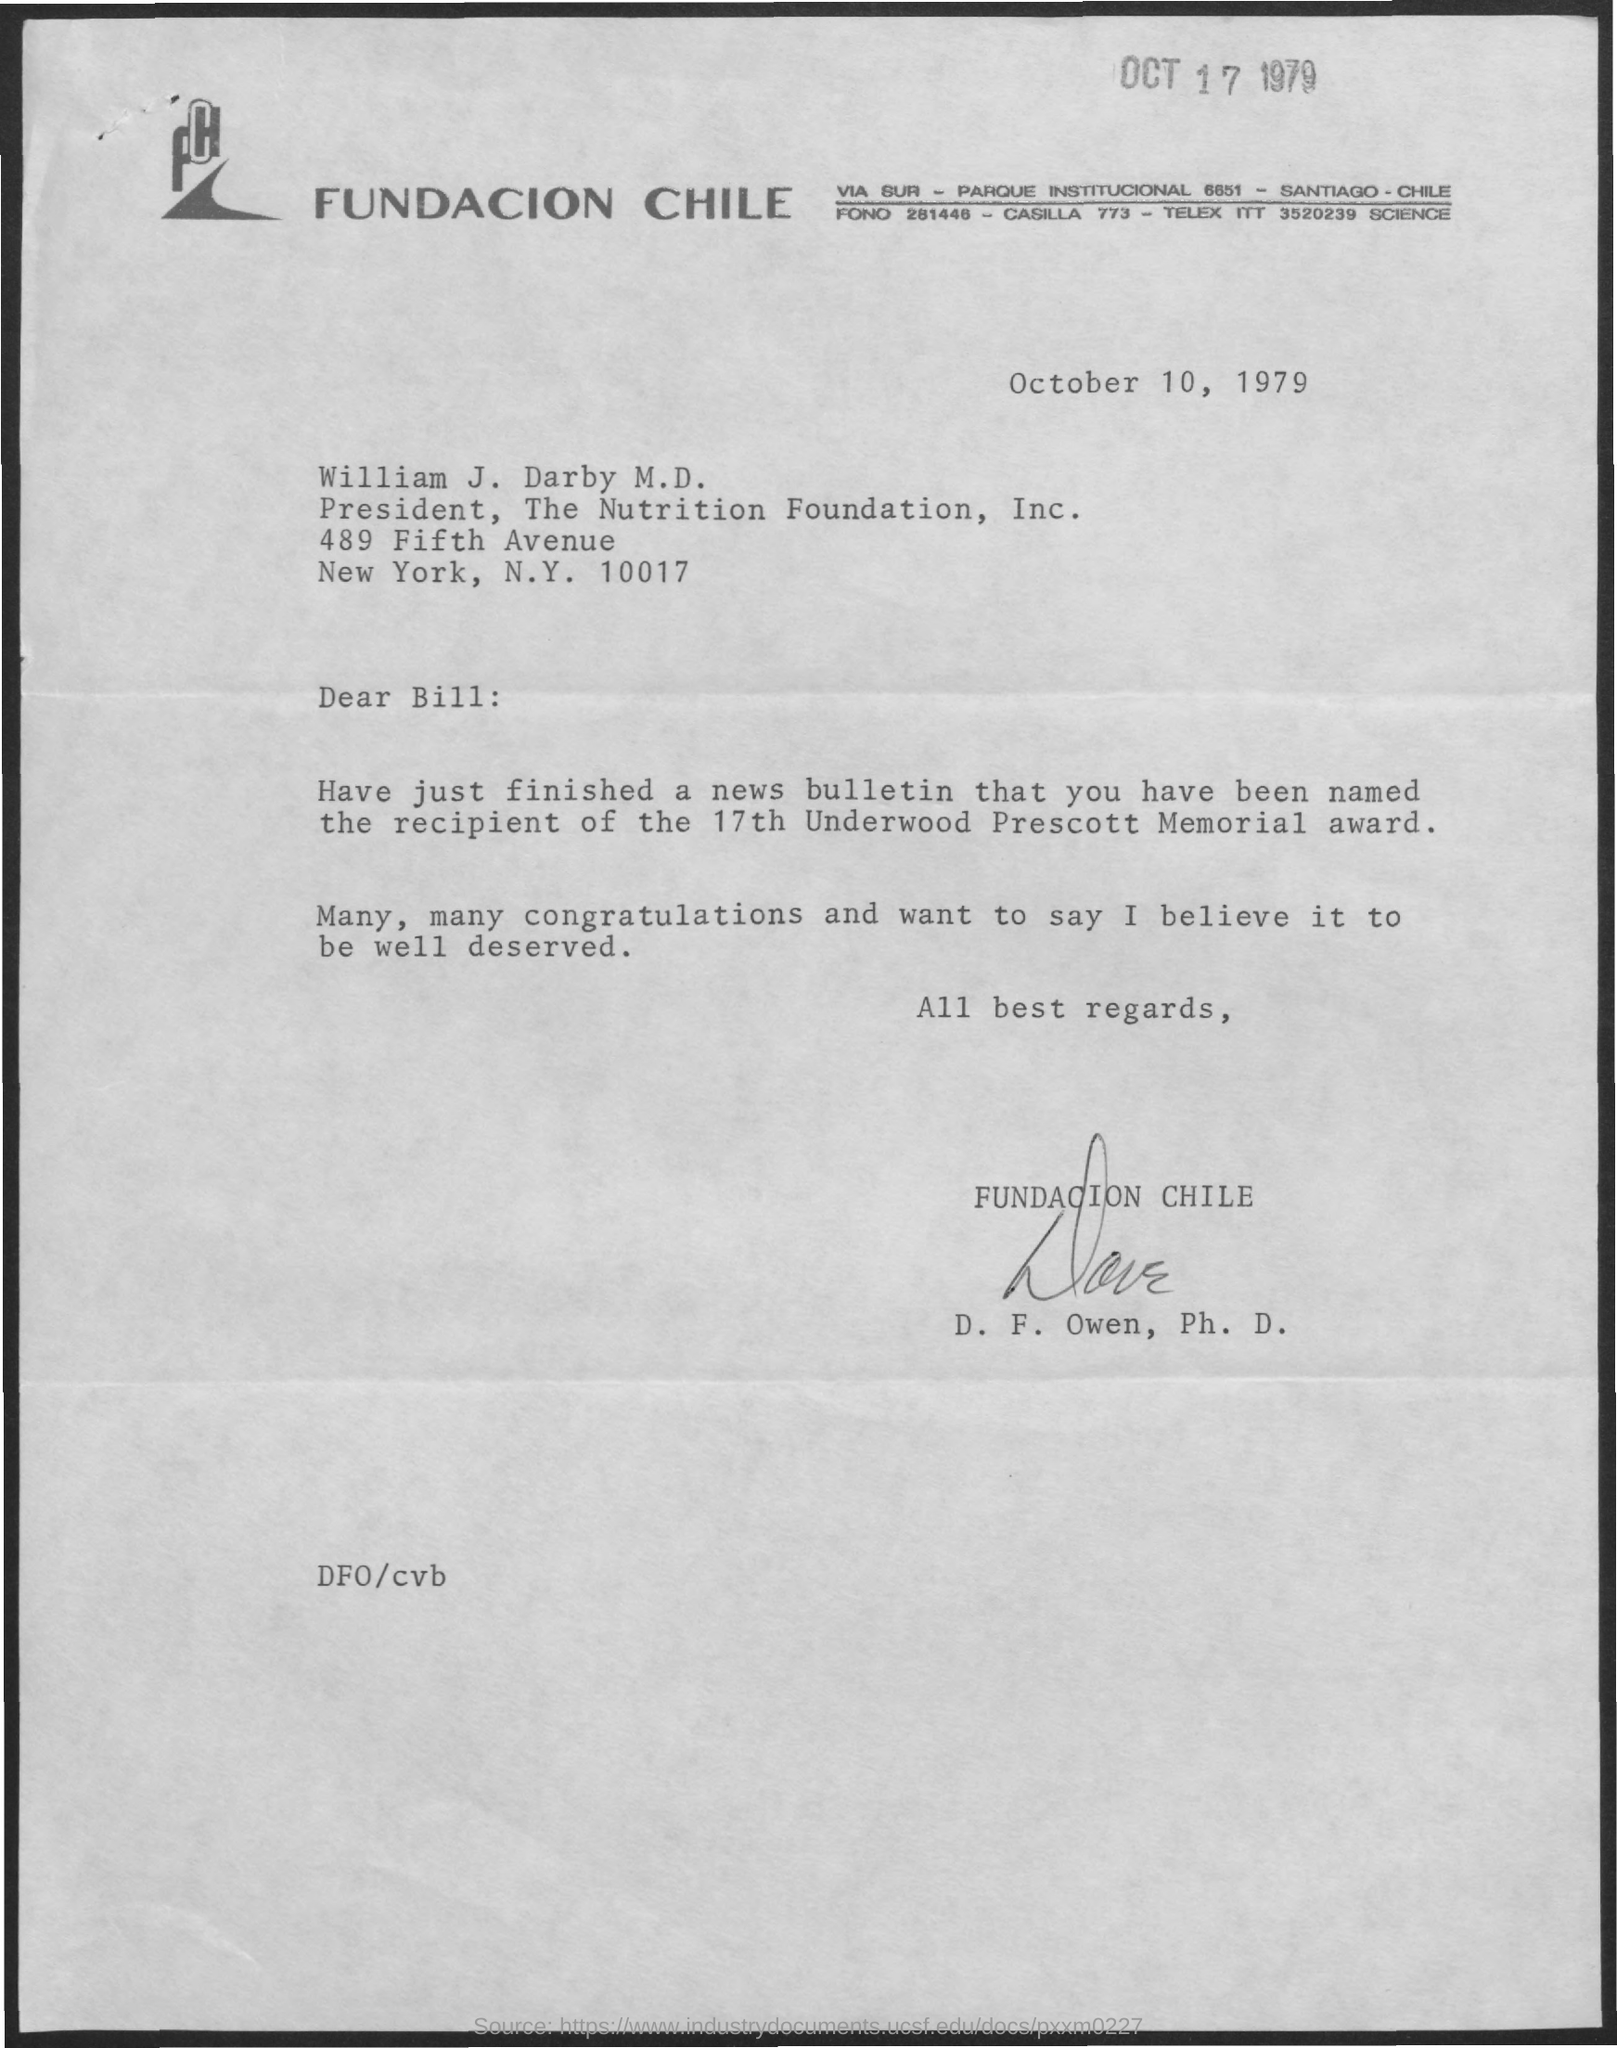Specify some key components in this picture. William J. Darby is designated as the President. The date mentioned at the top of the page is October 17, 1979. The signature at the bottom of the letter was that of D.F. Owen. The date mentioned on the given page is October 10, 1979. 